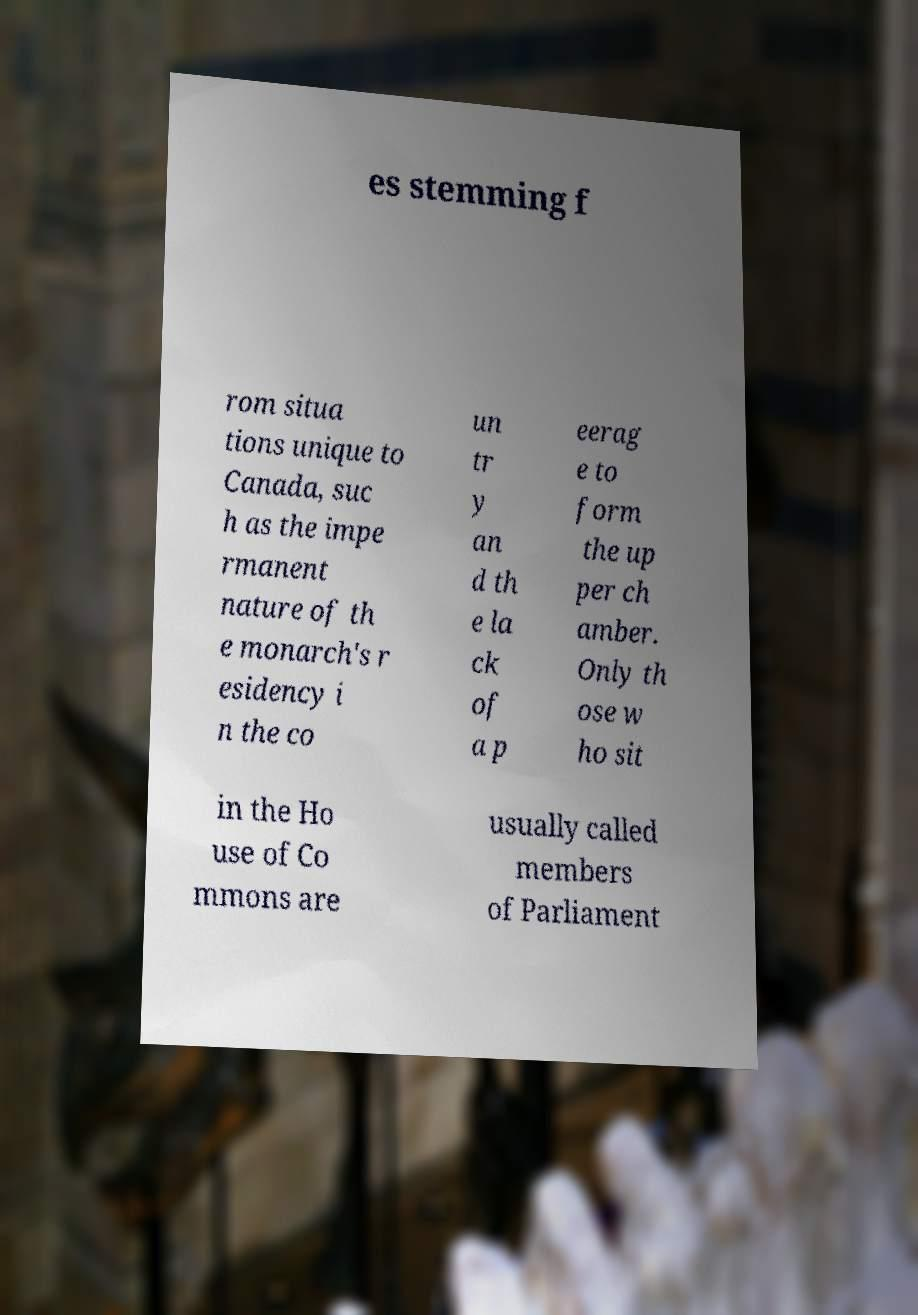Please read and relay the text visible in this image. What does it say? es stemming f rom situa tions unique to Canada, suc h as the impe rmanent nature of th e monarch's r esidency i n the co un tr y an d th e la ck of a p eerag e to form the up per ch amber. Only th ose w ho sit in the Ho use of Co mmons are usually called members of Parliament 